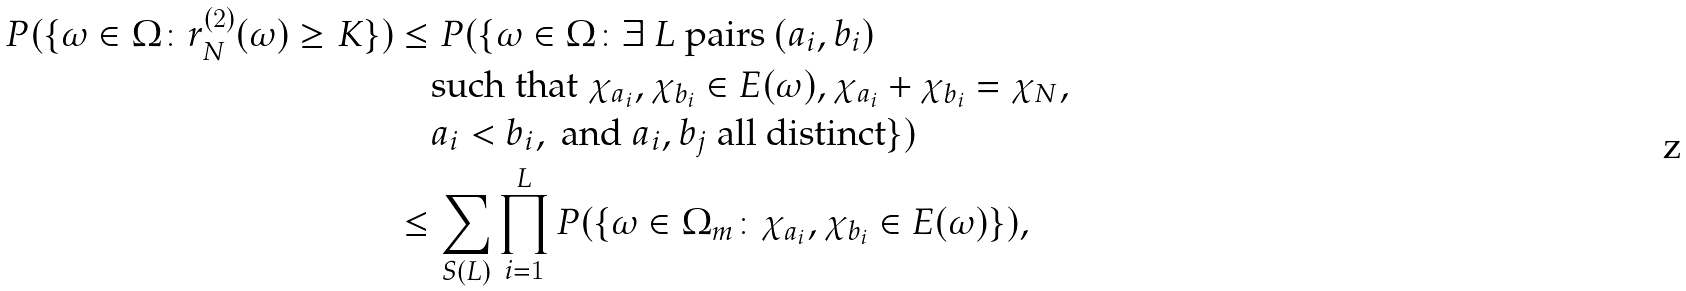<formula> <loc_0><loc_0><loc_500><loc_500>P ( \{ \omega \in \Omega \colon r _ { N } ^ { ( 2 ) } ( \omega ) \geq K \} ) & \leq P ( \{ \omega \in \Omega \colon \exists \ L \text { pairs } ( a _ { i } , b _ { i } ) \\ & \quad \text {such that } \chi _ { a _ { i } } , \chi _ { b _ { i } } \in E ( \omega ) , \chi _ { a _ { i } } + \chi _ { b _ { i } } = \chi _ { N } , \\ & \quad a _ { i } < b _ { i } , \text { and } a _ { i } , b _ { j } \text { all distinct} \} ) \\ & \leq \sum _ { S ( L ) } \prod _ { i = 1 } ^ { L } P ( \{ \omega \in \Omega _ { m } \colon \chi _ { a _ { i } } , \chi _ { b _ { i } } \in E ( \omega ) \} ) ,</formula> 